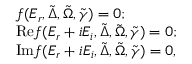<formula> <loc_0><loc_0><loc_500><loc_500>\begin{array} { r l } & { f ( E _ { r } , \tilde { \Delta } , \tilde { \Omega } , \tilde { \gamma } ) = 0 ; } \\ & { R e f ( E _ { r } + i E _ { i } , \tilde { \Delta } , \tilde { \Omega } , \tilde { \gamma } ) = 0 ; } \\ & { I m f ( E _ { r } + i E _ { i } , \tilde { \Delta } , \tilde { \Omega } , \tilde { \gamma } ) = 0 , } \end{array}</formula> 